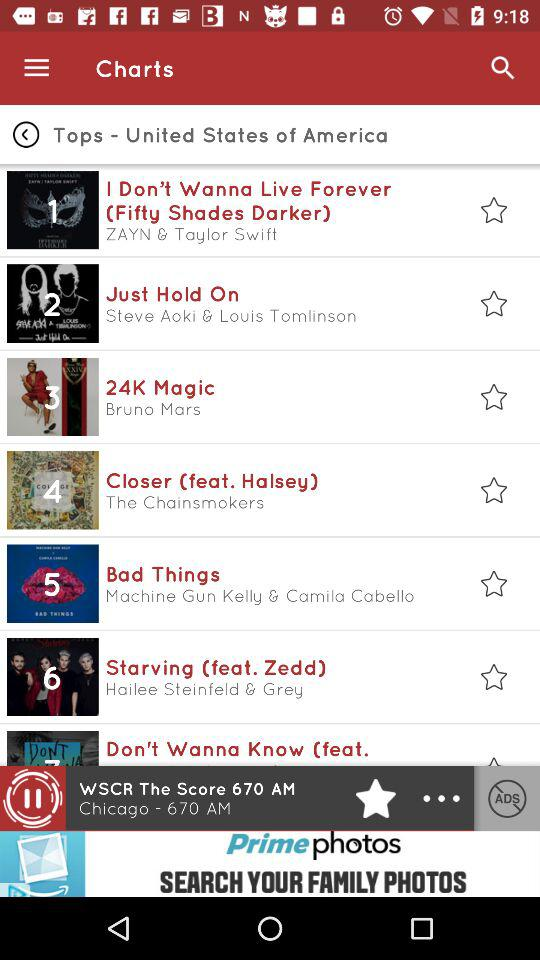Who is the singer of "Just Hold On"? The singers of "Just Hold On" are Steve Aoki and Louis Tomlinson. 